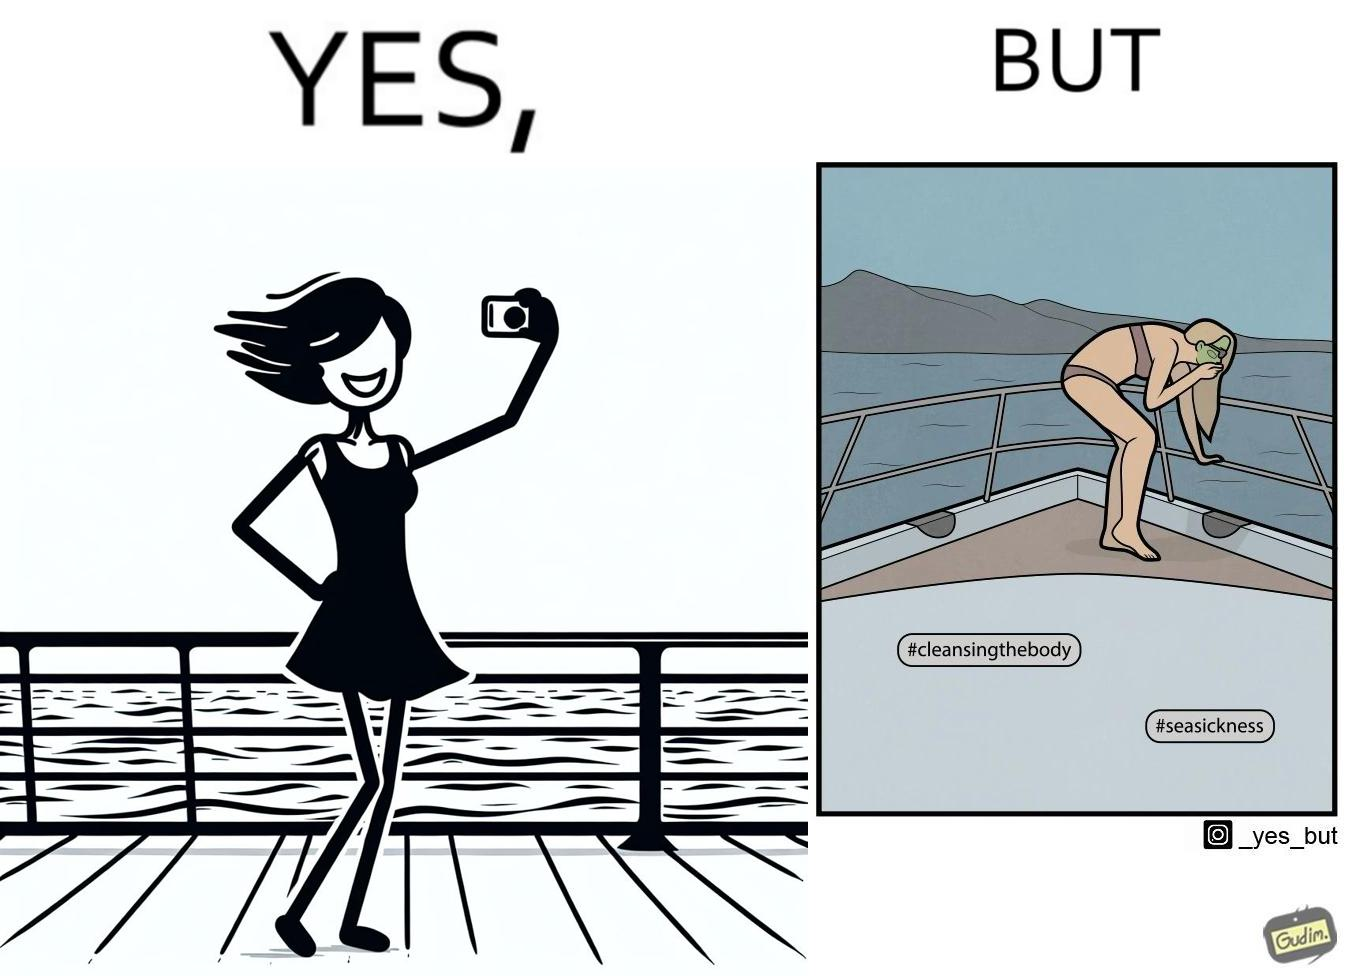Describe the contrast between the left and right parts of this image. In the left part of the image: a woman posing for a photo on a sea trip on how she is enjoying the trip In the right part of the image: a woman in a photo on a sea trip shown how she is feeling sick over the trip 